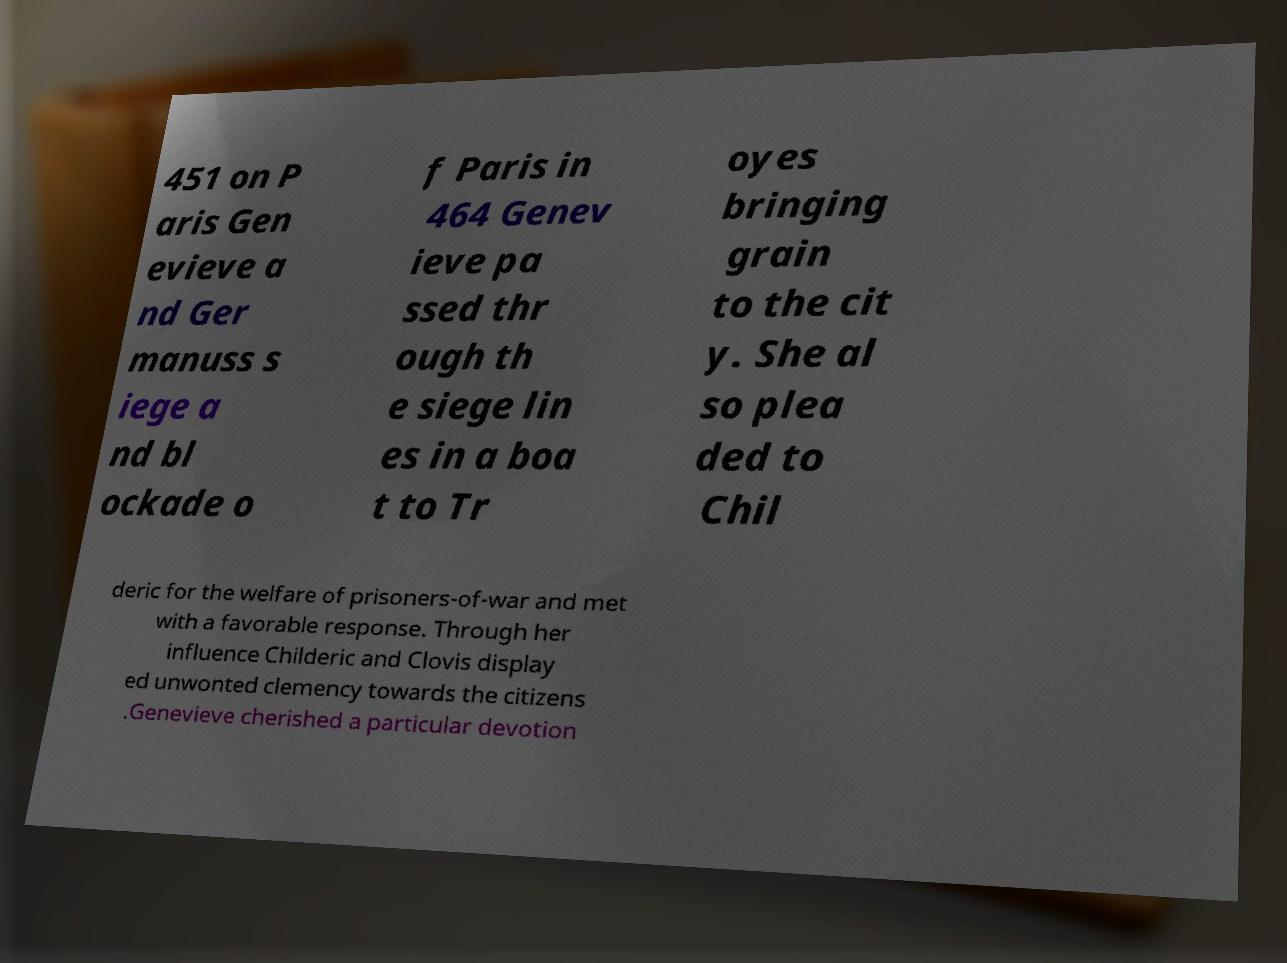There's text embedded in this image that I need extracted. Can you transcribe it verbatim? 451 on P aris Gen evieve a nd Ger manuss s iege a nd bl ockade o f Paris in 464 Genev ieve pa ssed thr ough th e siege lin es in a boa t to Tr oyes bringing grain to the cit y. She al so plea ded to Chil deric for the welfare of prisoners-of-war and met with a favorable response. Through her influence Childeric and Clovis display ed unwonted clemency towards the citizens .Genevieve cherished a particular devotion 